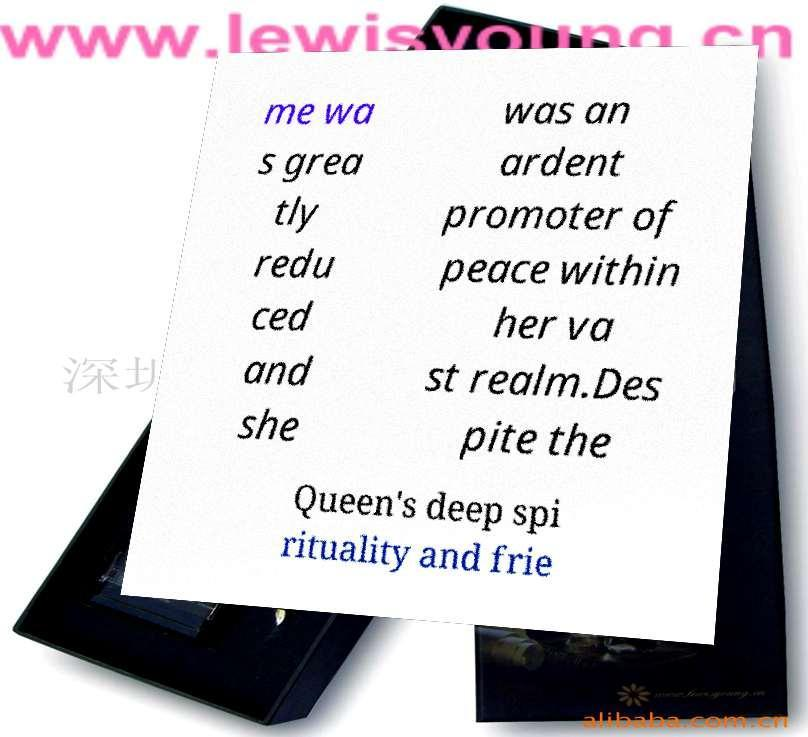Please read and relay the text visible in this image. What does it say? me wa s grea tly redu ced and she was an ardent promoter of peace within her va st realm.Des pite the Queen's deep spi rituality and frie 